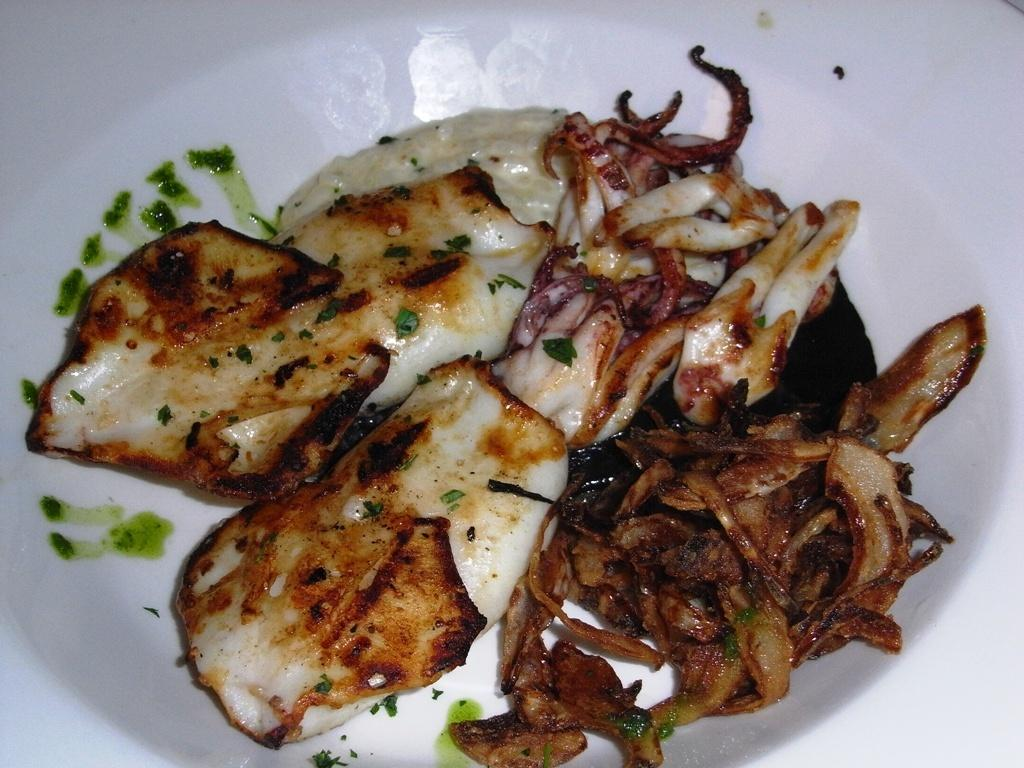What is the color of the main object in the image? The main object in the image is white. What is placed on the white object? Food is present on the white object. Can you describe the colors of the food? The food has colors of white, cream, green, and brown. What type of gun can be seen in the image? There is no gun present in the image. How does the sock contribute to the overall appearance of the image? There is no sock present in the image. 